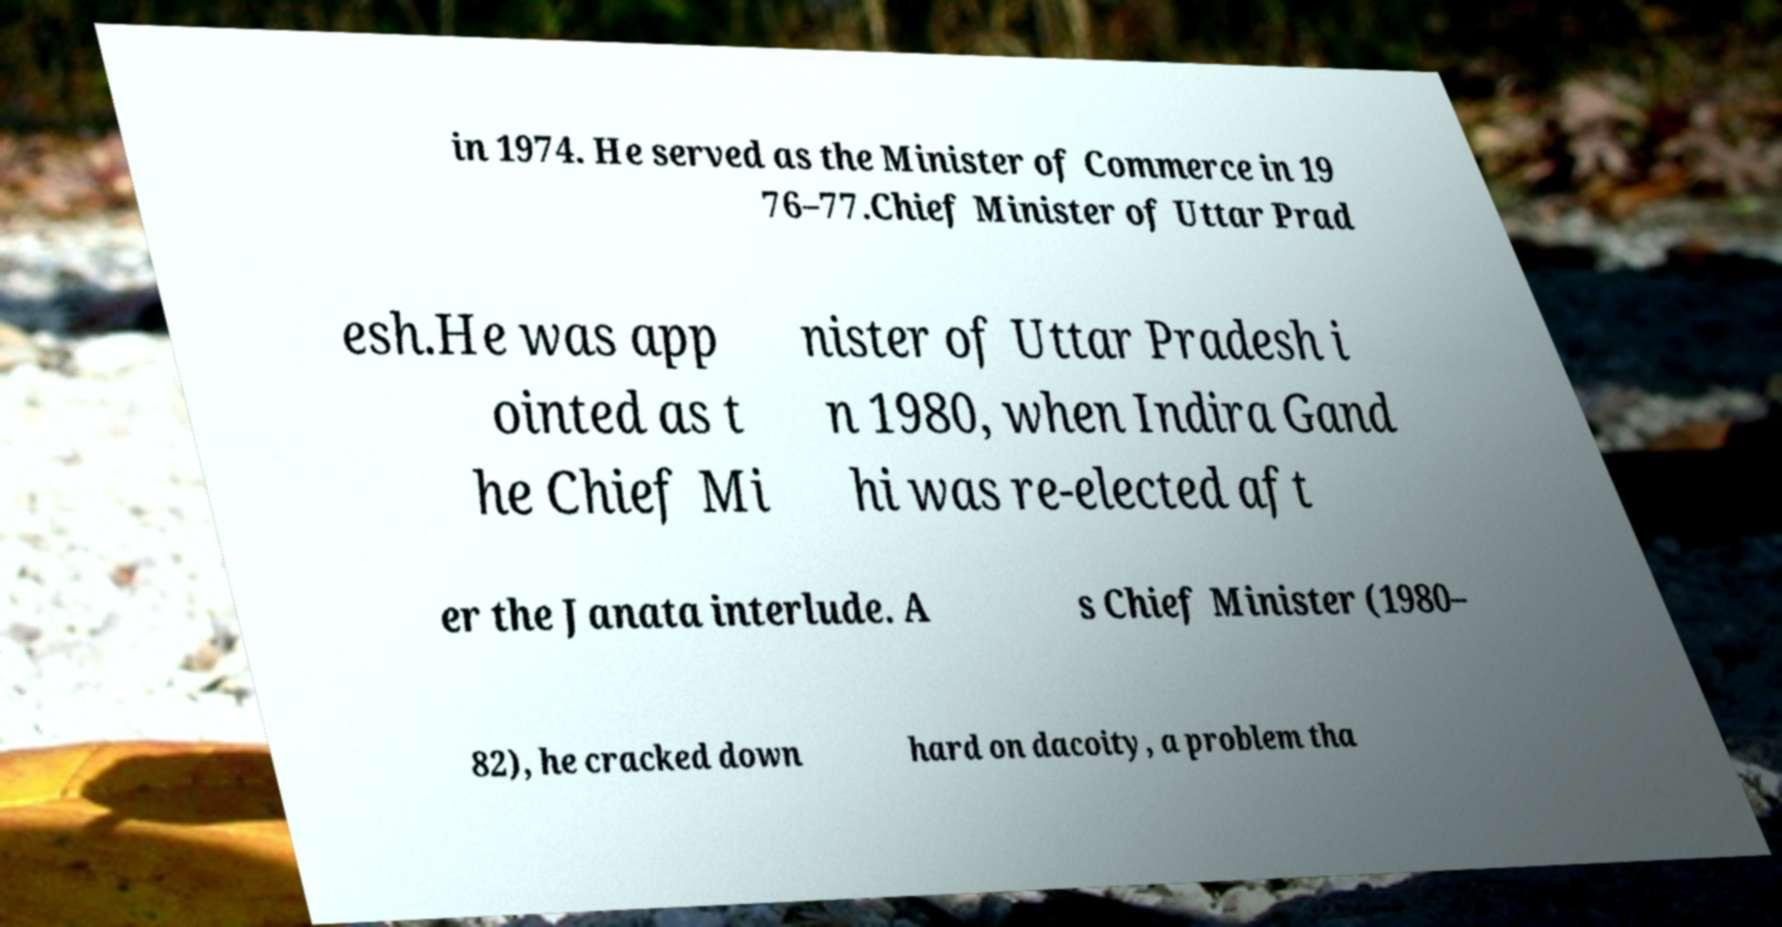Please read and relay the text visible in this image. What does it say? in 1974. He served as the Minister of Commerce in 19 76–77.Chief Minister of Uttar Prad esh.He was app ointed as t he Chief Mi nister of Uttar Pradesh i n 1980, when Indira Gand hi was re-elected aft er the Janata interlude. A s Chief Minister (1980– 82), he cracked down hard on dacoity, a problem tha 